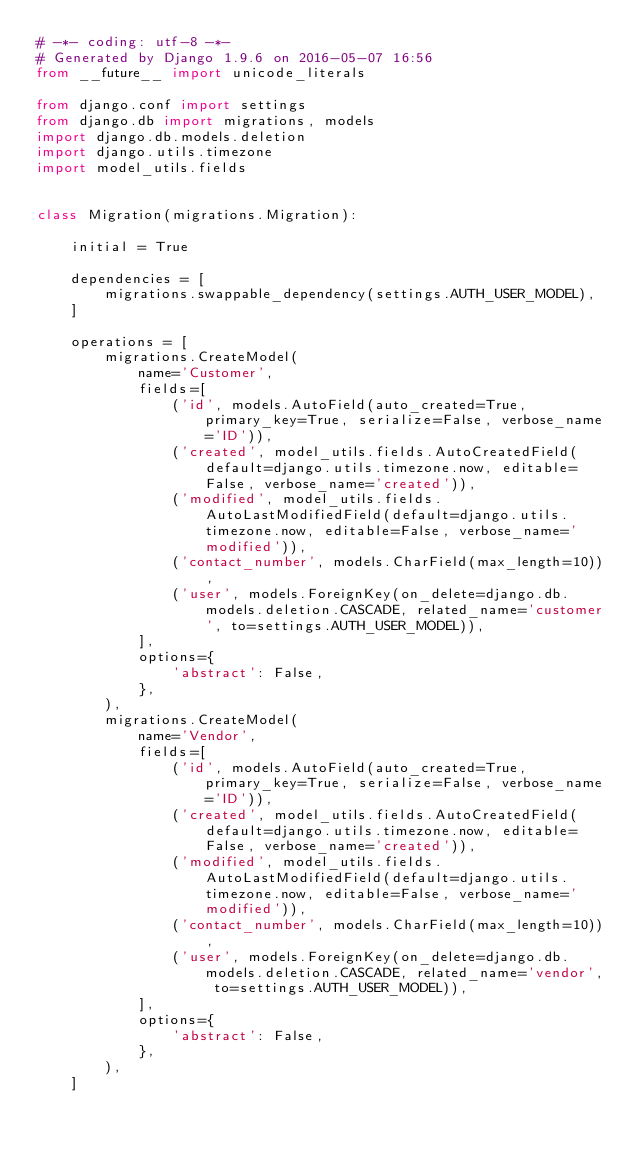<code> <loc_0><loc_0><loc_500><loc_500><_Python_># -*- coding: utf-8 -*-
# Generated by Django 1.9.6 on 2016-05-07 16:56
from __future__ import unicode_literals

from django.conf import settings
from django.db import migrations, models
import django.db.models.deletion
import django.utils.timezone
import model_utils.fields


class Migration(migrations.Migration):

    initial = True

    dependencies = [
        migrations.swappable_dependency(settings.AUTH_USER_MODEL),
    ]

    operations = [
        migrations.CreateModel(
            name='Customer',
            fields=[
                ('id', models.AutoField(auto_created=True, primary_key=True, serialize=False, verbose_name='ID')),
                ('created', model_utils.fields.AutoCreatedField(default=django.utils.timezone.now, editable=False, verbose_name='created')),
                ('modified', model_utils.fields.AutoLastModifiedField(default=django.utils.timezone.now, editable=False, verbose_name='modified')),
                ('contact_number', models.CharField(max_length=10)),
                ('user', models.ForeignKey(on_delete=django.db.models.deletion.CASCADE, related_name='customer', to=settings.AUTH_USER_MODEL)),
            ],
            options={
                'abstract': False,
            },
        ),
        migrations.CreateModel(
            name='Vendor',
            fields=[
                ('id', models.AutoField(auto_created=True, primary_key=True, serialize=False, verbose_name='ID')),
                ('created', model_utils.fields.AutoCreatedField(default=django.utils.timezone.now, editable=False, verbose_name='created')),
                ('modified', model_utils.fields.AutoLastModifiedField(default=django.utils.timezone.now, editable=False, verbose_name='modified')),
                ('contact_number', models.CharField(max_length=10)),
                ('user', models.ForeignKey(on_delete=django.db.models.deletion.CASCADE, related_name='vendor', to=settings.AUTH_USER_MODEL)),
            ],
            options={
                'abstract': False,
            },
        ),
    ]
</code> 